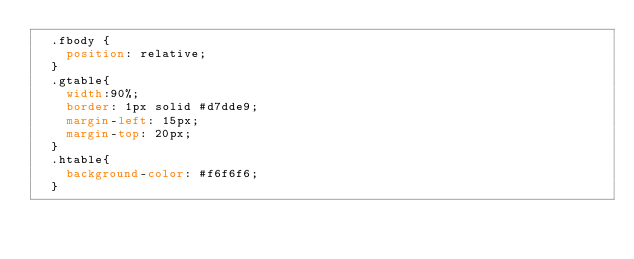<code> <loc_0><loc_0><loc_500><loc_500><_CSS_>  .fbody {
    position: relative;
  }
  .gtable{
    width:90%; 
    border: 1px solid #d7dde9; 
    margin-left: 15px;
    margin-top: 20px;
  }
  .htable{
    background-color: #f6f6f6;
  }</code> 